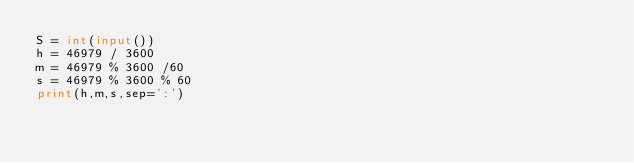Convert code to text. <code><loc_0><loc_0><loc_500><loc_500><_Python_>S = int(input())
h = 46979 / 3600
m = 46979 % 3600 /60
s = 46979 % 3600 % 60
print(h,m,s,sep=':')</code> 